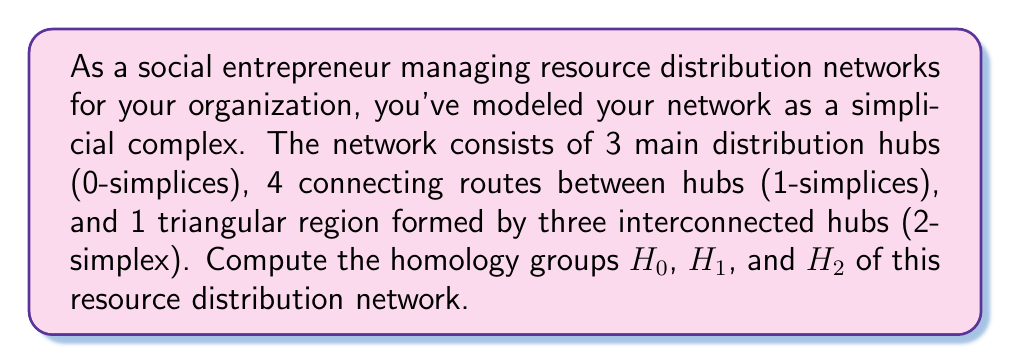Could you help me with this problem? To compute the homology groups, we'll follow these steps:

1. Determine the chain complex:
   $$C_2 \xrightarrow{\partial_2} C_1 \xrightarrow{\partial_1} C_0$$

2. Calculate the boundary maps:
   $\partial_2: C_2 \to C_1$ and $\partial_1: C_1 \to C_0$

3. Find the kernel and image of each boundary map.

4. Compute the homology groups using the formula:
   $$H_n = \frac{\text{ker}(\partial_n)}{\text{im}(\partial_{n+1})}$$

Step 1: Chain complex
- $C_0$ has dimension 3 (3 distribution hubs)
- $C_1$ has dimension 4 (4 connecting routes)
- $C_2$ has dimension 1 (1 triangular region)

Step 2: Boundary maps
- $\partial_2([v_0, v_1, v_2]) = [v_1, v_2] - [v_0, v_2] + [v_0, v_1]$
- $\partial_1([v_i, v_j]) = v_j - v_i$

Step 3: Kernels and images
- $\text{ker}(\partial_2) = \{0\}$ (trivial)
- $\text{im}(\partial_2) = \text{span}\{[v_1, v_2] - [v_0, v_2] + [v_0, v_1]\}$ (1-dimensional)
- $\text{ker}(\partial_1) = \text{span}\{[v_0, v_1] + [v_1, v_2] - [v_0, v_2]\}$ (1-dimensional)
- $\text{im}(\partial_1) = \text{span}\{v_1 - v_0, v_2 - v_1, v_2 - v_0\}$ (2-dimensional)

Step 4: Homology groups
- $H_0 = \frac{C_0}{\text{im}(\partial_1)} \cong \mathbb{Z}$ (connected component)
- $H_1 = \frac{\text{ker}(\partial_1)}{\text{im}(\partial_2)} \cong \{0\}$ (no holes)
- $H_2 = \text{ker}(\partial_2) \cong \{0\}$ (no voids)
Answer: The homology groups of the resource distribution network are:
$H_0 \cong \mathbb{Z}$, $H_1 \cong \{0\}$, and $H_2 \cong \{0\}$. 